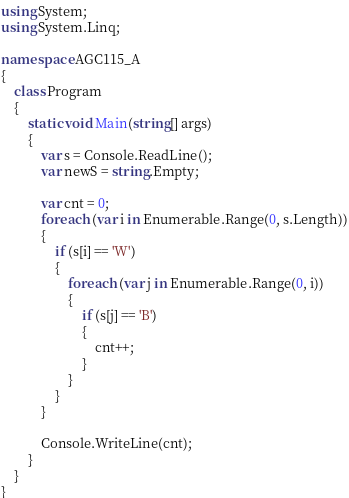<code> <loc_0><loc_0><loc_500><loc_500><_C#_>using System;
using System.Linq;

namespace AGC115_A
{
    class Program
    {
        static void Main(string[] args)
        {
            var s = Console.ReadLine();
            var newS = string.Empty;

            var cnt = 0;
            foreach (var i in Enumerable.Range(0, s.Length))
            {
                if (s[i] == 'W')
                {
                    foreach (var j in Enumerable.Range(0, i))
                    {
                        if (s[j] == 'B')
                        {
                            cnt++;
                        }
                    }
                }
            }

            Console.WriteLine(cnt);
        }
    }
}
</code> 